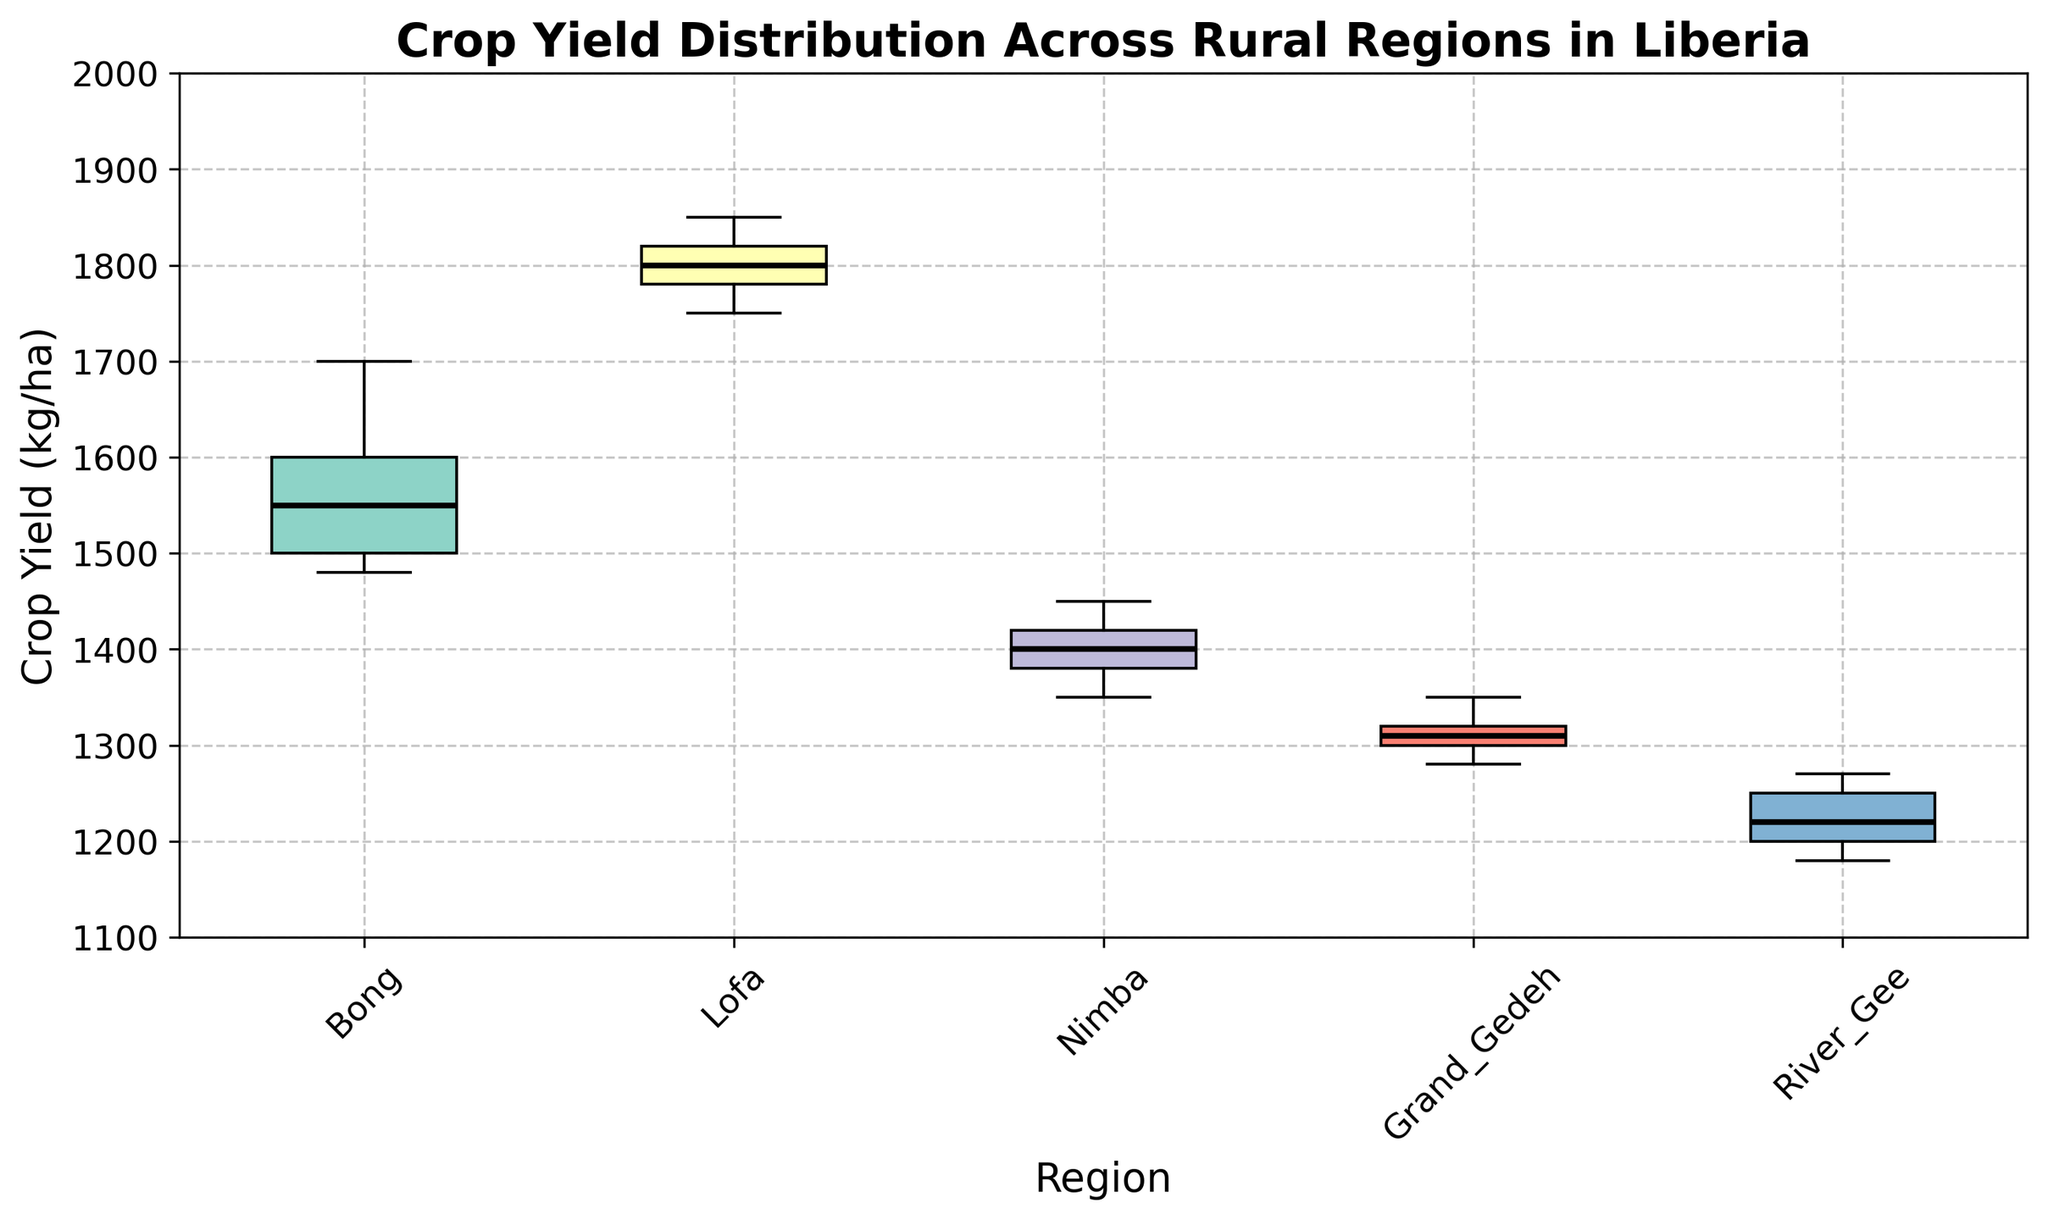Which region has the highest median crop yield? The box plot shows the median as the horizontal line inside each box. The region with the highest median crop yield will have the highest median line.
Answer: Lofa What is the range of crop yield values for Bong? The upper and lower edges of the box represent the interquartile range, and the whiskers represent the total range including potential outliers. Calculate the range by subtracting the minimum from the maximum value shown.
Answer: 1480 – 1700 Which region has the lowest maximum crop yield? The maximum crop yield is represented by the top whisker in each box plot. Identify the lowest top whisker among the regions.
Answer: River Gee How does the median crop yield in Nimba compare to that in Bong? Compare the median lines (horizontal black lines) inside the boxes of Nimba and Bong.
Answer: The median crop yield in Nimba is lower than in Bong Which region has the most consistent crop yields (smallest interquartile range)? The interquartile range is represented by the height of each box. Look for the region with the smallest box.
Answer: Grand Gedeh What is the approximate interquartile range (IQR) for Lofa? The IQR is the difference between the upper quartile (top of the box) and the lower quartile (bottom of the box). Identify these values from the box and subtract the lower from the upper.
Answer: ~70 kg/ha Is there any region whose crop yield has outliers, and if so, which region? Outliers are usually represented by individual points outside the whiskers of the box plot. Identify any region with such points.
Answer: No regions have outliers Between River Gee and Grand Gedeh, which region has a wider variability in crop yields? Variability is indicated by the length of the whiskers and the size of the box. Compare these elements for both regions.
Answer: River Gee What is the total range of crop yields for Lofa? The total range is the difference between the maximum and minimum crop yields as shown by the whiskers. Identify these values and subtract the minimum from the maximum.
Answer: 1750 - 1850 What information does the title of the box plot convey about the data presented? The title provides an overview of what the box plot represents. It mentions "Crop Yield Distribution Across Rural Regions in Liberia."
Answer: It shows crop yield distribution across various rural regions in Liberia 